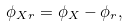Convert formula to latex. <formula><loc_0><loc_0><loc_500><loc_500>\phi _ { X r } = \phi _ { X } - \phi _ { r } ,</formula> 